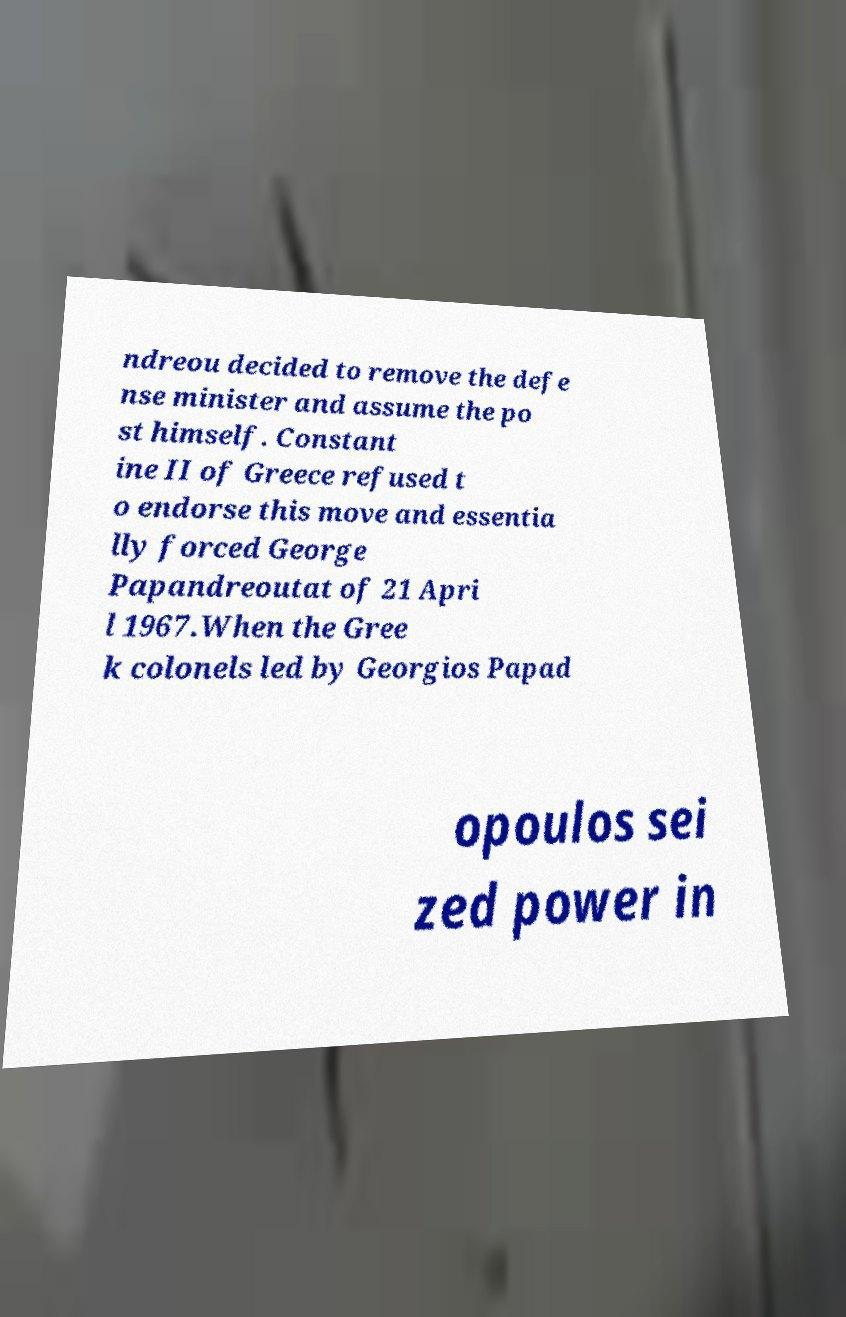Can you read and provide the text displayed in the image?This photo seems to have some interesting text. Can you extract and type it out for me? ndreou decided to remove the defe nse minister and assume the po st himself. Constant ine II of Greece refused t o endorse this move and essentia lly forced George Papandreoutat of 21 Apri l 1967.When the Gree k colonels led by Georgios Papad opoulos sei zed power in 